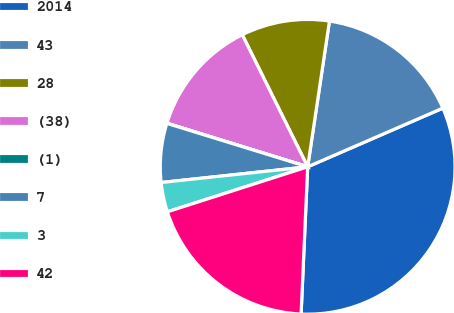Convert chart. <chart><loc_0><loc_0><loc_500><loc_500><pie_chart><fcel>2014<fcel>43<fcel>28<fcel>(38)<fcel>(1)<fcel>7<fcel>3<fcel>42<nl><fcel>32.23%<fcel>16.12%<fcel>9.68%<fcel>12.9%<fcel>0.02%<fcel>6.46%<fcel>3.24%<fcel>19.35%<nl></chart> 